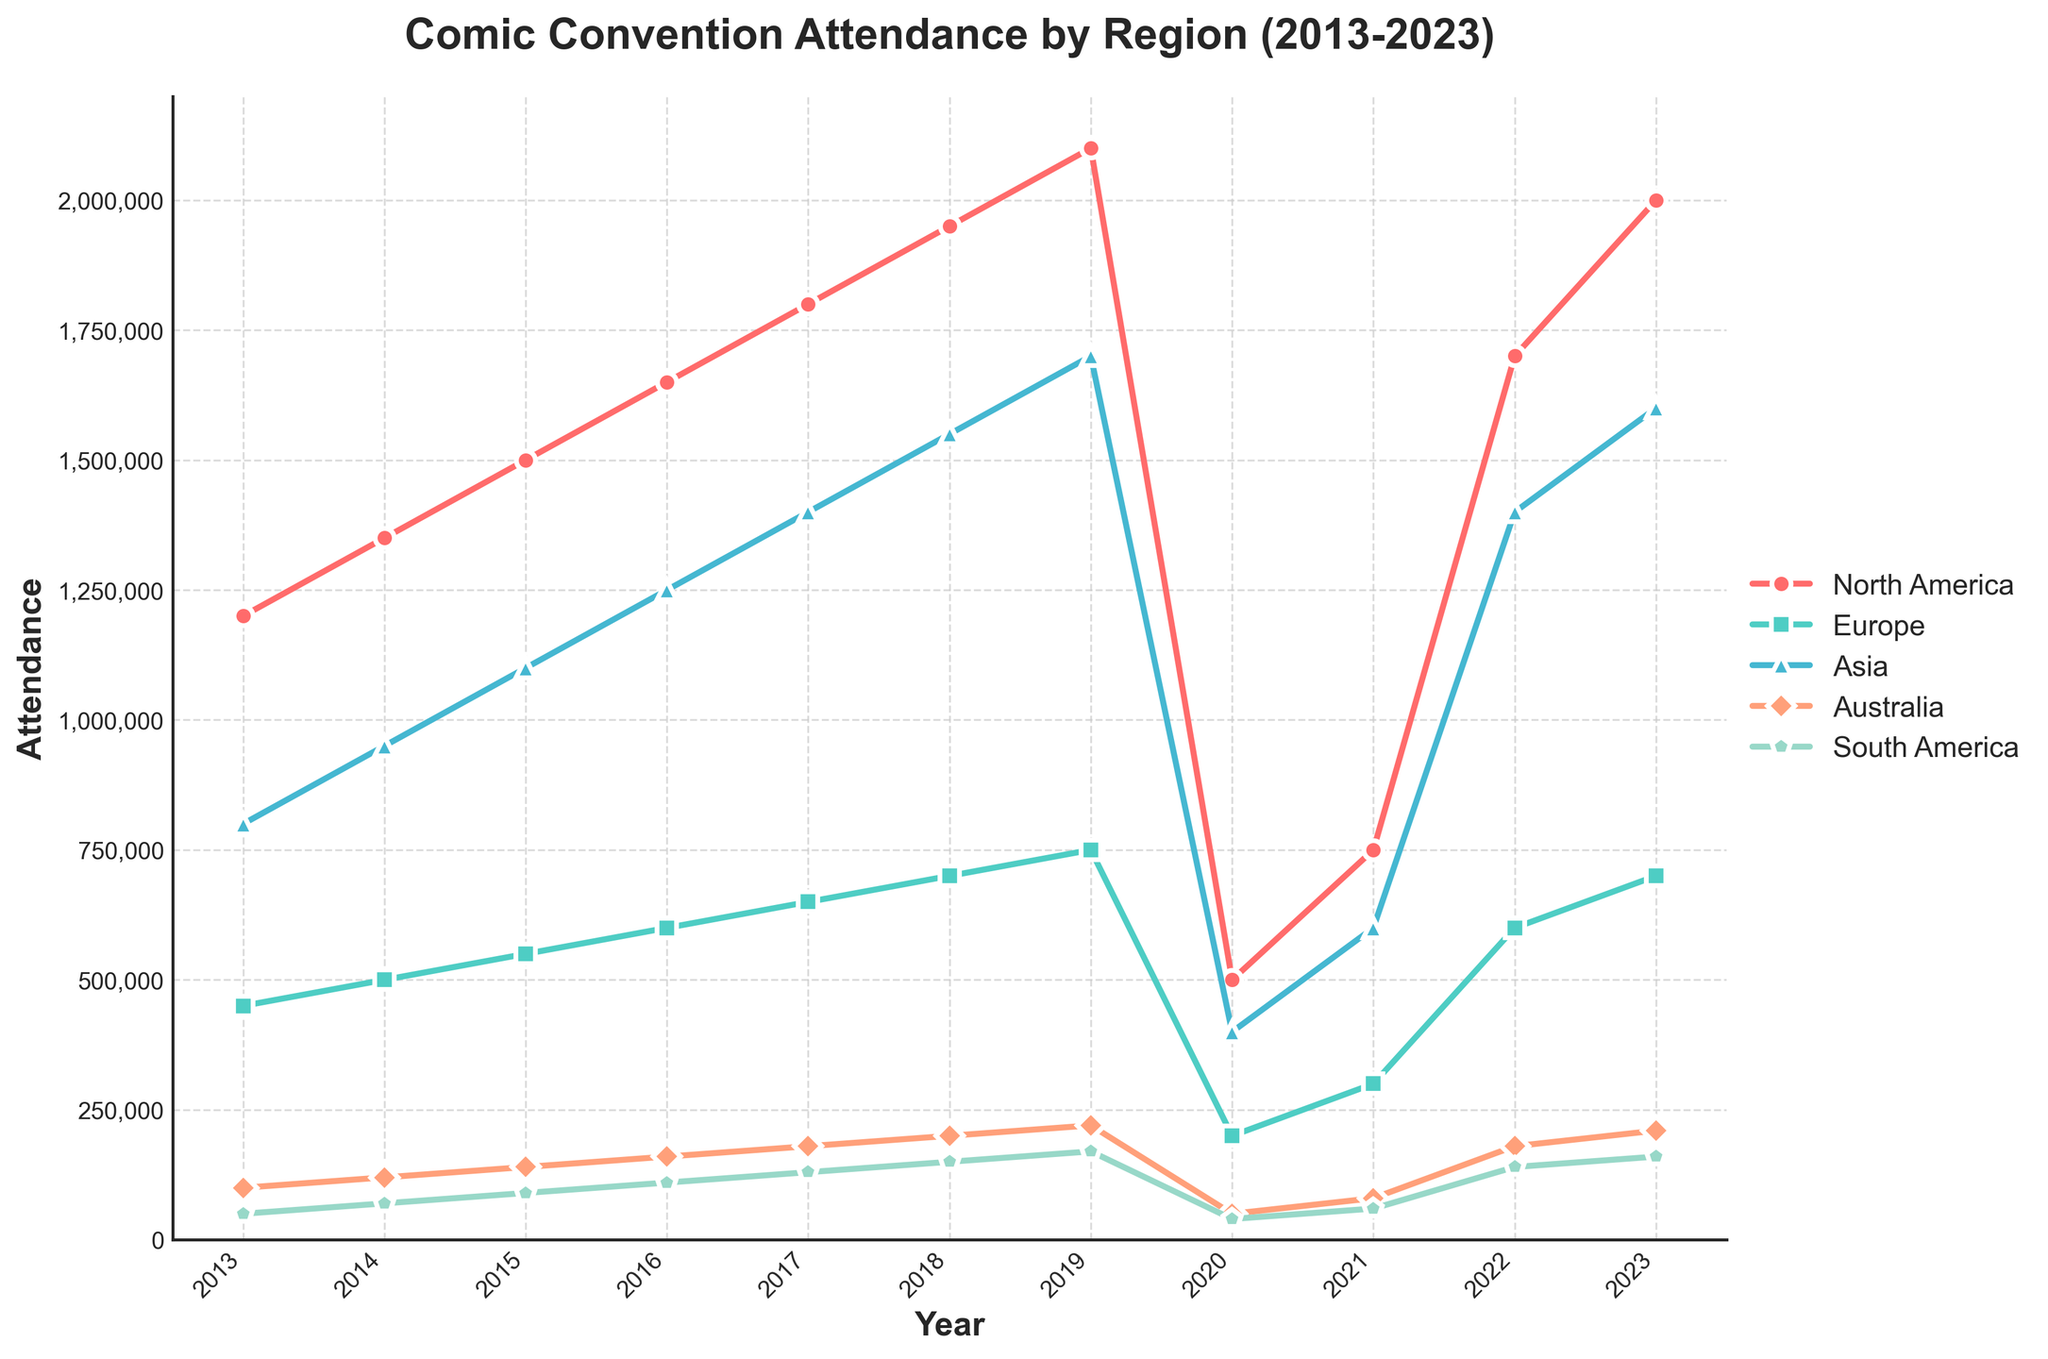What region had the highest attendance overall in 2023? By visually examining the endpoints of the lines for 2023, the North America line reaches the highest attendance value.
Answer: North America Which region experienced the sharpest drop in attendance between 2019 and 2020? Compare the drop in attendance for each region between the years 2019 to 2020. Asia's line shows the most significant drop.
Answer: Asia What is the average attendance of comic conventions in Europe from 2013 to 2023? Sum the attendance values for Europe from 2013 to 2023 and divide by the number of years (11). Sum: 450,000 + 500,000 + 550,000 + 600,000 + 650,000 + 700,000 + 750,000 + 200,000 + 300,000 + 600,000 + 700,000 = 5,500,000. Average: 5,500,000 / 11 ≈ 500,000.
Answer: 500,000 How did South America's attendance in 2023 compare to its attendance in 2017? Look at the attendance values for South America in 2023 (160,000) and 2017 (130,000). 2023 attendance is higher.
Answer: Higher Which year saw the lowest overall attendance across all regions combined? Examine the combined attendance for all regions for each year. The year 2020 shows the lowest combined attendance.
Answer: 2020 By how much did North America's attendance increase from 2013 to 2019? Subtract North America's attendance in 2013 (1,200,000) from its attendance in 2019 (2,100,000). Difference: 2,100,000 - 1,200,000 = 900,000.
Answer: 900,000 What was the percentage increase in attendance for Asia from 2013 to 2017? Calculate the percentage increase from 800,000 (2013) to 1,400,000 (2017) for Asia. Percentage increase = [(1,400,000 - 800,000) / 800,000] * 100 ≈ 75%.
Answer: 75% Which region had the most consistent increase in attendance from 2013 to 2019? Assess the annual increase in attendance for each region. North America had a consistent year-on-year increase.
Answer: North America Based on the visual trends, which region is likely to recover the fastest post-2020? Examine the upward trend lines post-2020. Both North America and Asia show steep recoveries, suggesting they are recovering the fastest.
Answer: North America and Asia What is the total combined attendance for all regions in 2023? Sum the attendance values for all regions in 2023. Total: 2,000,000 (North America) + 700,000 (Europe) + 1,600,000 (Asia) + 210,000 (Australia) + 160,000 (South America) = 4,670,000.
Answer: 4,670,000 